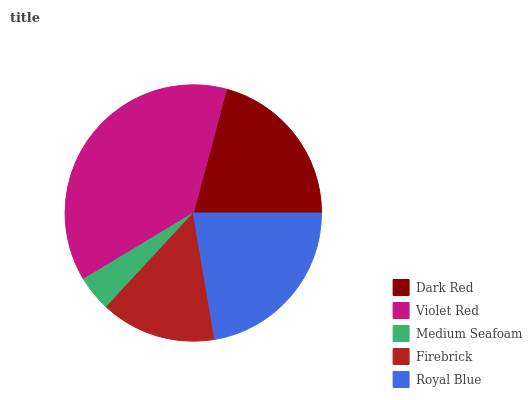Is Medium Seafoam the minimum?
Answer yes or no. Yes. Is Violet Red the maximum?
Answer yes or no. Yes. Is Violet Red the minimum?
Answer yes or no. No. Is Medium Seafoam the maximum?
Answer yes or no. No. Is Violet Red greater than Medium Seafoam?
Answer yes or no. Yes. Is Medium Seafoam less than Violet Red?
Answer yes or no. Yes. Is Medium Seafoam greater than Violet Red?
Answer yes or no. No. Is Violet Red less than Medium Seafoam?
Answer yes or no. No. Is Dark Red the high median?
Answer yes or no. Yes. Is Dark Red the low median?
Answer yes or no. Yes. Is Medium Seafoam the high median?
Answer yes or no. No. Is Firebrick the low median?
Answer yes or no. No. 